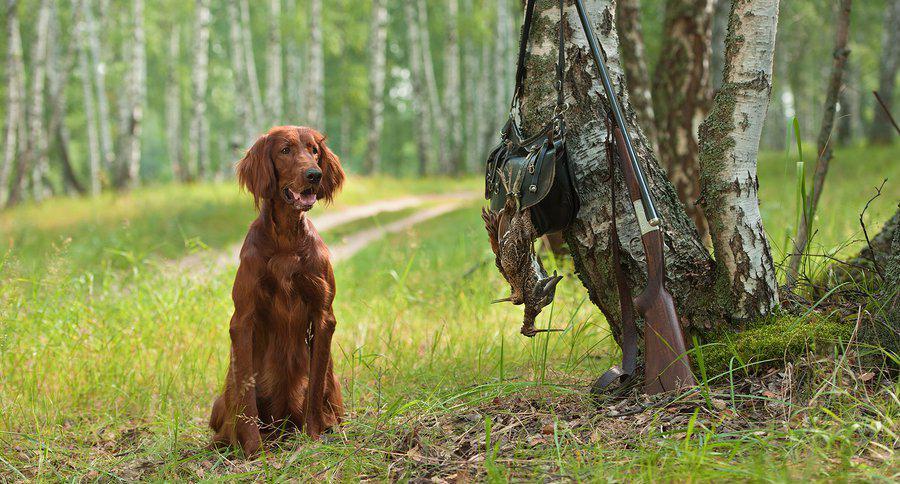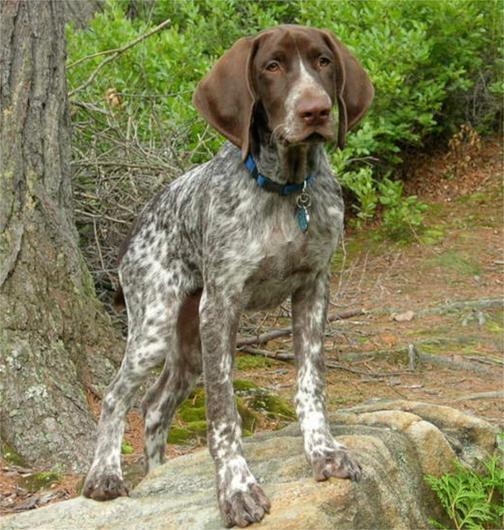The first image is the image on the left, the second image is the image on the right. Examine the images to the left and right. Is the description "A dog is sitting in the right image." accurate? Answer yes or no. No. The first image is the image on the left, the second image is the image on the right. Considering the images on both sides, is "The right image features a dog on something elevated, and the left image includes a dog and at least one dead game bird." valid? Answer yes or no. Yes. 